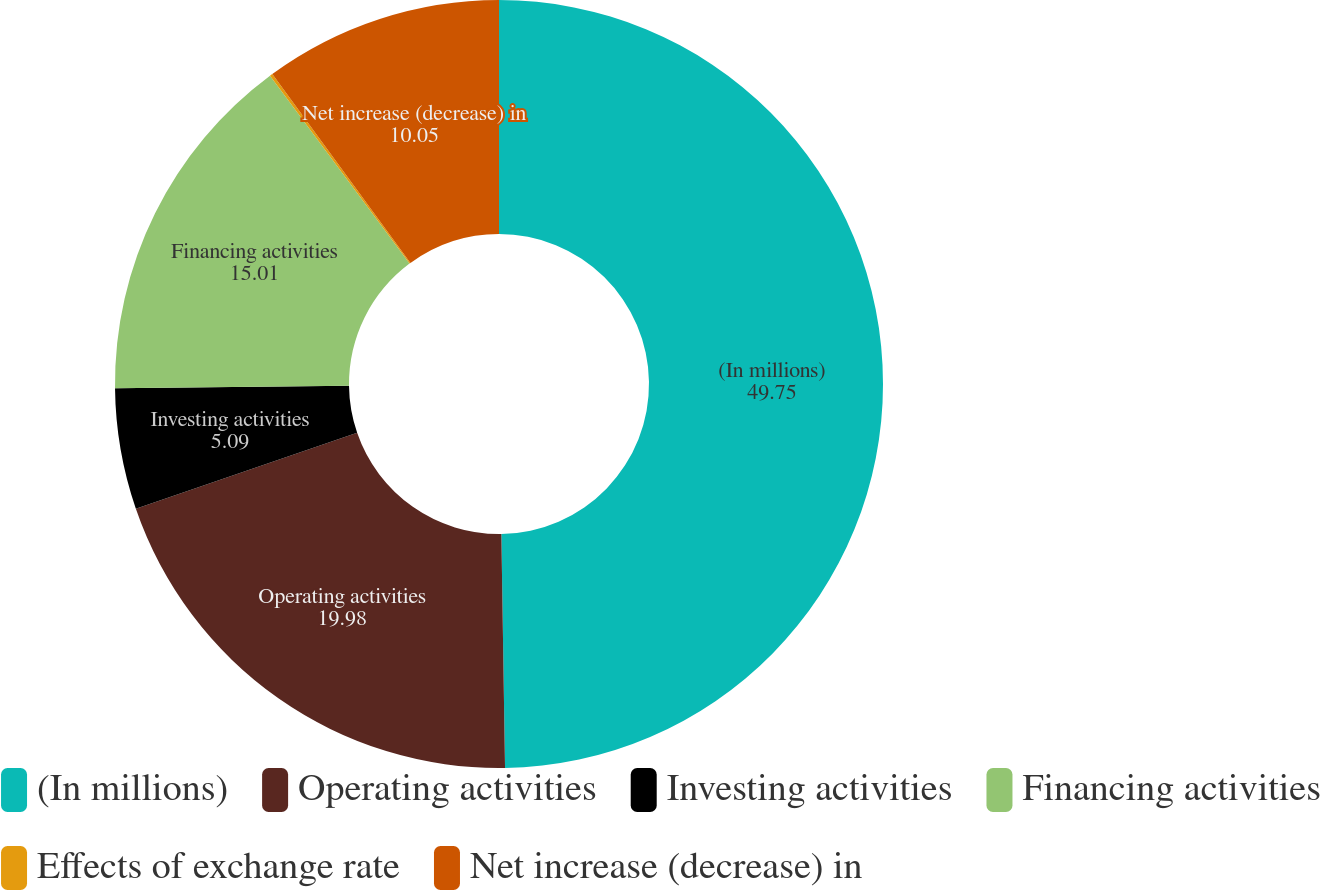Convert chart to OTSL. <chart><loc_0><loc_0><loc_500><loc_500><pie_chart><fcel>(In millions)<fcel>Operating activities<fcel>Investing activities<fcel>Financing activities<fcel>Effects of exchange rate<fcel>Net increase (decrease) in<nl><fcel>49.75%<fcel>19.98%<fcel>5.09%<fcel>15.01%<fcel>0.12%<fcel>10.05%<nl></chart> 